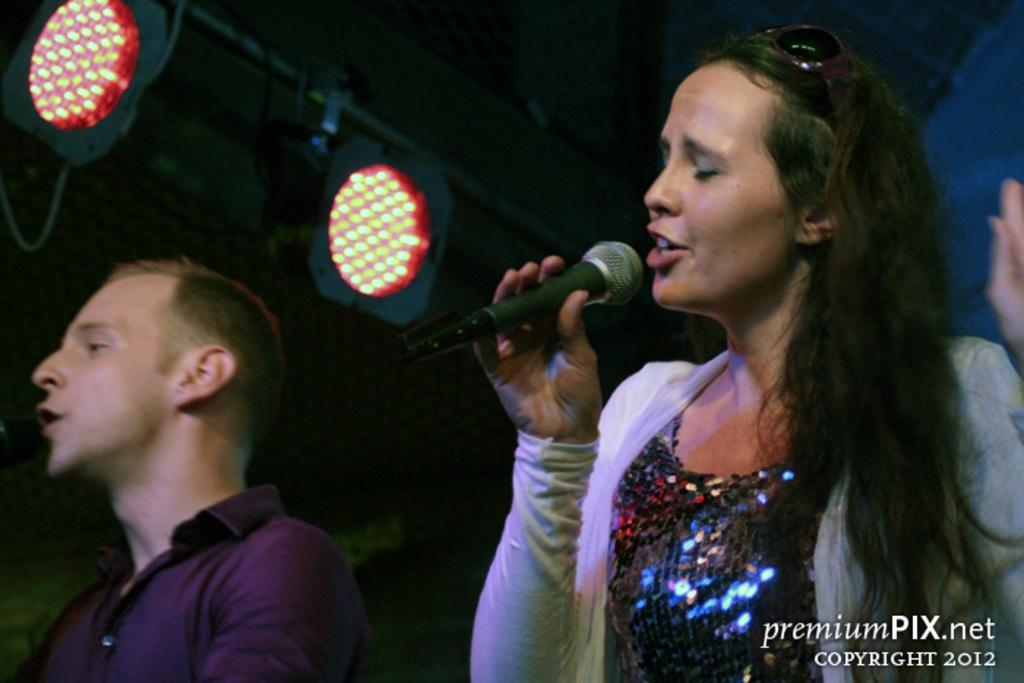How many people are in the image? There are two persons in the image: a man and a woman. What is the woman holding in the image? The woman is holding a microphone. What are the man and the woman doing in the image? The woman and the man are singing. Can you describe the lighting in the image? There are two lights in the top left corner of the image. What is written or displayed in the bottom right corner of the image? There is text in the bottom right corner of the image. What type of fairies can be seen flying around the microphone in the image? There are no fairies present in the image; it features a man and a woman singing with a microphone. What does the taste of the lunch being served in the image suggest about the quality of the food? There is no mention of lunch or food in the image, so it is not possible to determine the taste or quality of any meal. 